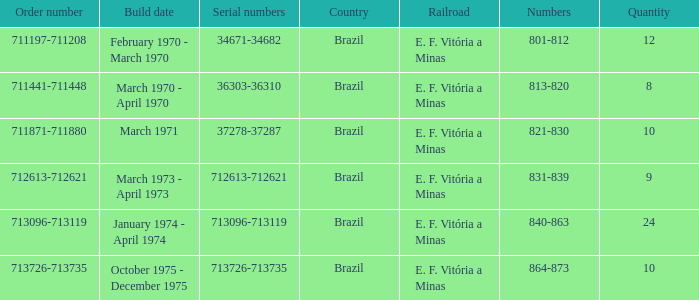Which nation possesses the sequence number 711871-711880? Brazil. 